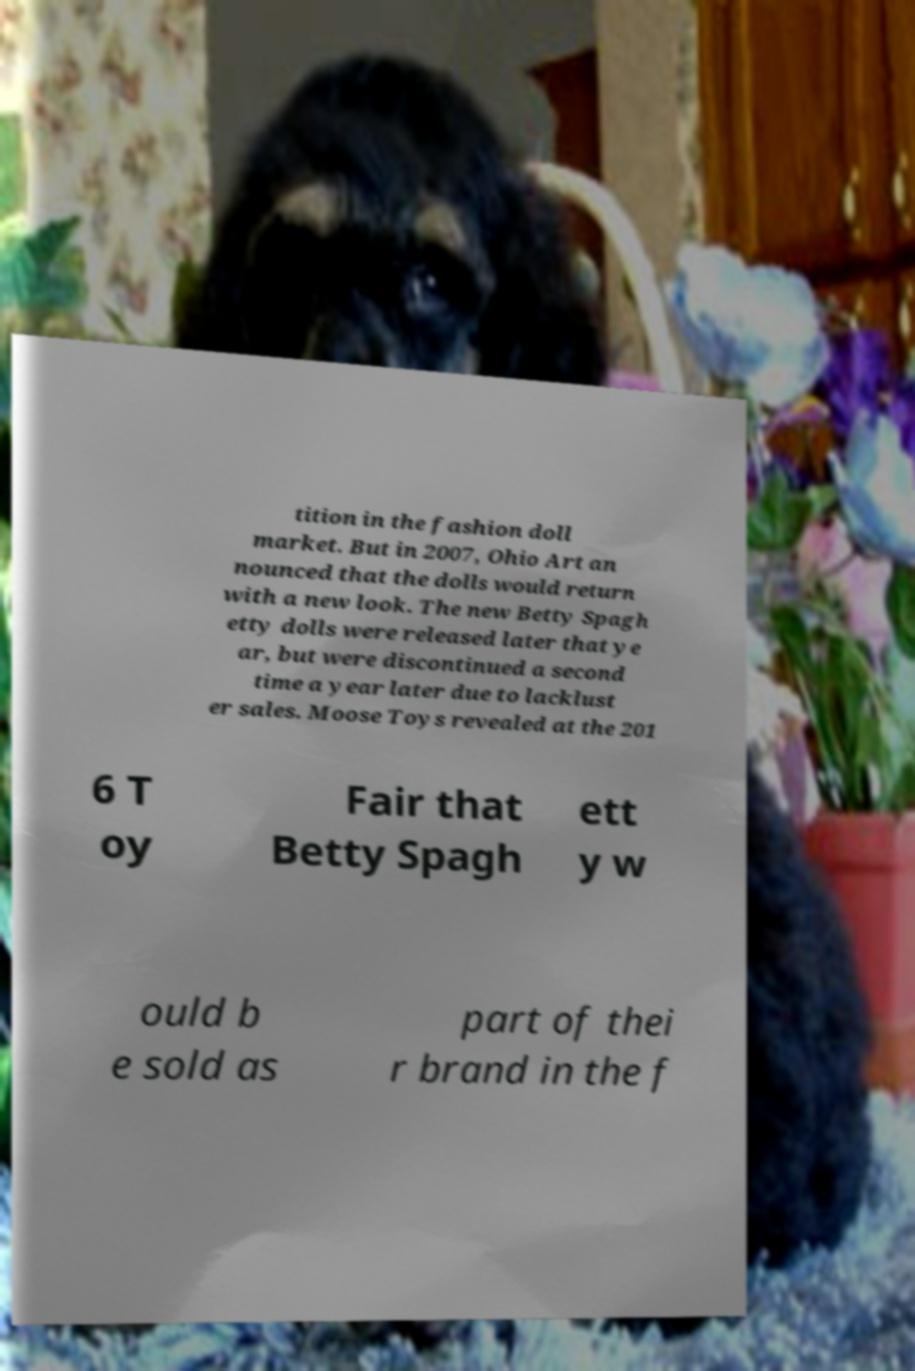Please identify and transcribe the text found in this image. tition in the fashion doll market. But in 2007, Ohio Art an nounced that the dolls would return with a new look. The new Betty Spagh etty dolls were released later that ye ar, but were discontinued a second time a year later due to lacklust er sales. Moose Toys revealed at the 201 6 T oy Fair that Betty Spagh ett y w ould b e sold as part of thei r brand in the f 